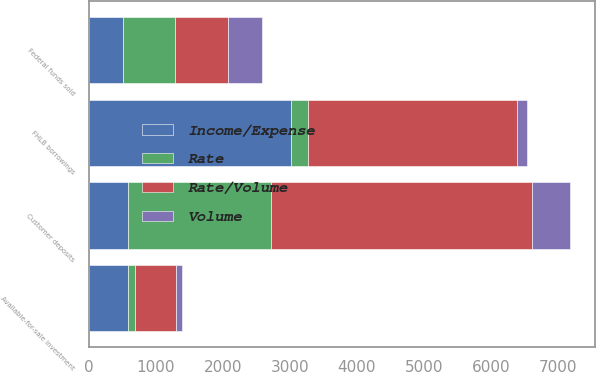<chart> <loc_0><loc_0><loc_500><loc_500><stacked_bar_chart><ecel><fcel>Available-for-sale investment<fcel>Federal funds sold<fcel>Customer deposits<fcel>FHLB borrowings<nl><fcel>Rate/Volume<fcel>611<fcel>792<fcel>3895<fcel>3116<nl><fcel>Volume<fcel>86<fcel>500<fcel>573<fcel>149<nl><fcel>Income/Expense<fcel>580<fcel>515<fcel>580<fcel>3013<nl><fcel>Rate<fcel>117<fcel>777<fcel>2135<fcel>252<nl></chart> 